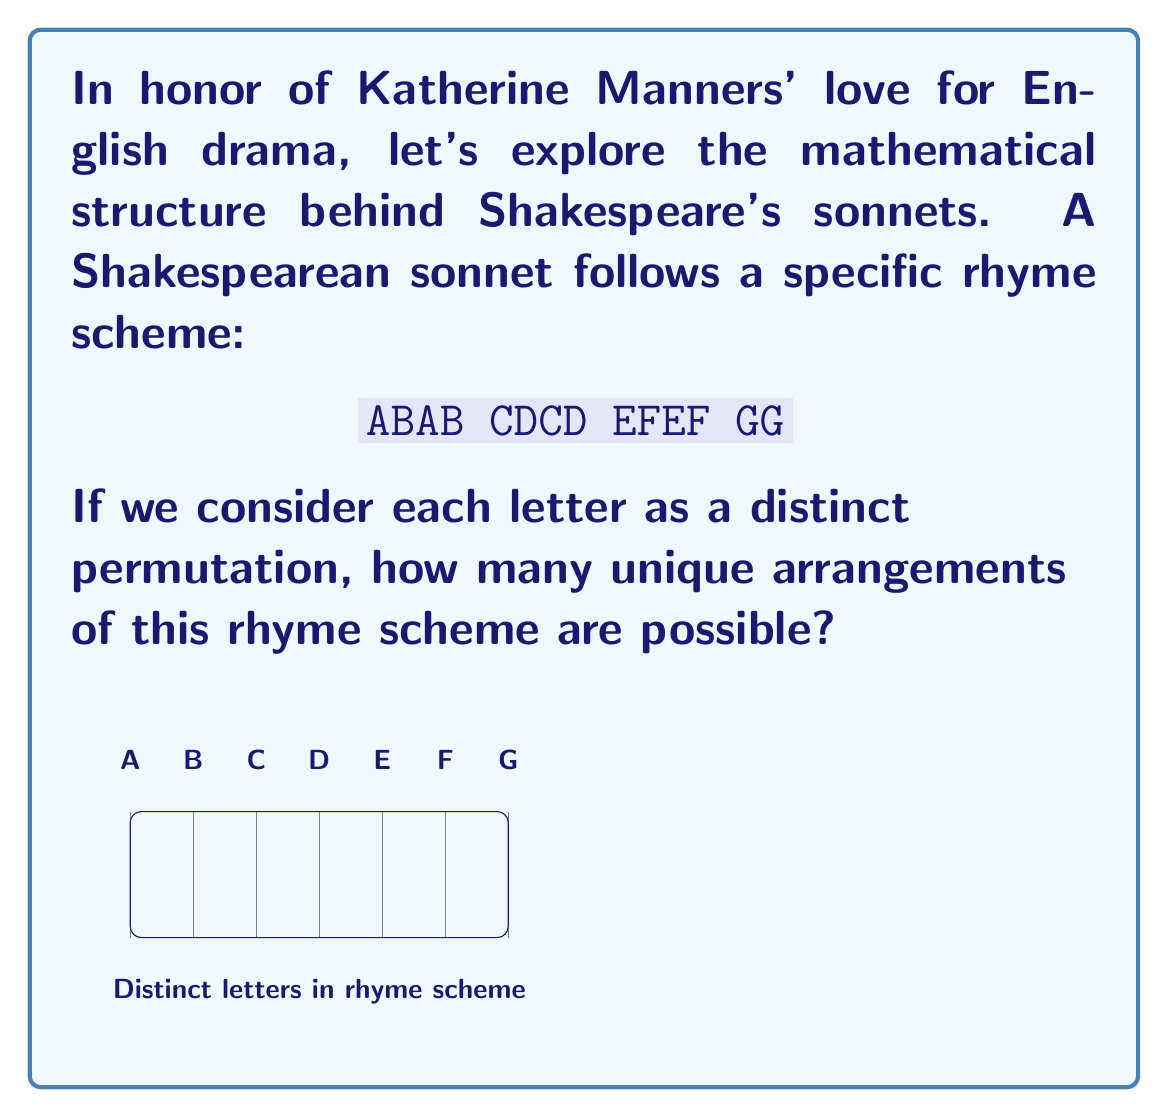Can you answer this question? To solve this problem, we need to consider the following steps:

1) First, let's identify the distinct elements in the rhyme scheme:
   A, B, C, D, E, F, G

2) We have 7 distinct elements to arrange.

3) In group theory, this is a permutation problem. The number of permutations of n distinct objects is given by n!

4) Therefore, the number of permutations is:

   $$7! = 7 \times 6 \times 5 \times 4 \times 3 \times 2 \times 1 = 5040$$

5) However, we need to consider that the order within each pair (AB, CD, EF) doesn't matter. For example, ABAB is equivalent to BABA in terms of rhyme scheme.

6) For each of these three pairs, we have 2! = 2 possible arrangements.

7) Therefore, we need to divide our total by $2^3 = 8$ to account for these equivalent arrangements:

   $$\frac{7!}{2^3} = \frac{5040}{8} = 630$$

Thus, there are 630 distinct permutations of the Shakespearean sonnet rhyme scheme.
Answer: 630 